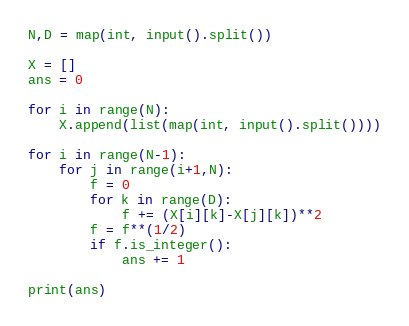Convert code to text. <code><loc_0><loc_0><loc_500><loc_500><_Python_>N,D = map(int, input().split())

X = []
ans = 0

for i in range(N):
    X.append(list(map(int, input().split())))

for i in range(N-1):
    for j in range(i+1,N):
        f = 0
        for k in range(D):
            f += (X[i][k]-X[j][k])**2
        f = f**(1/2)
        if f.is_integer():
            ans += 1

print(ans)
</code> 